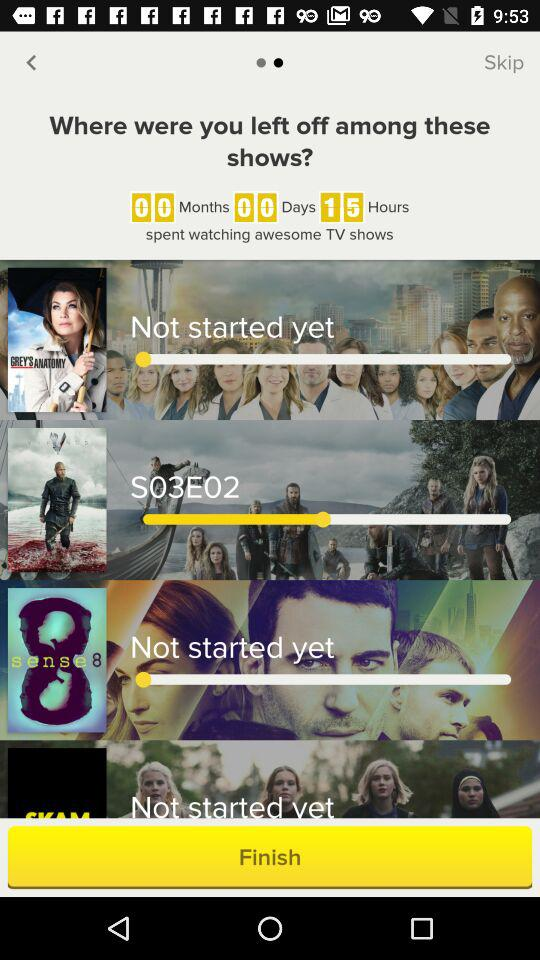How many shows have you not started yet?
Answer the question using a single word or phrase. 3 